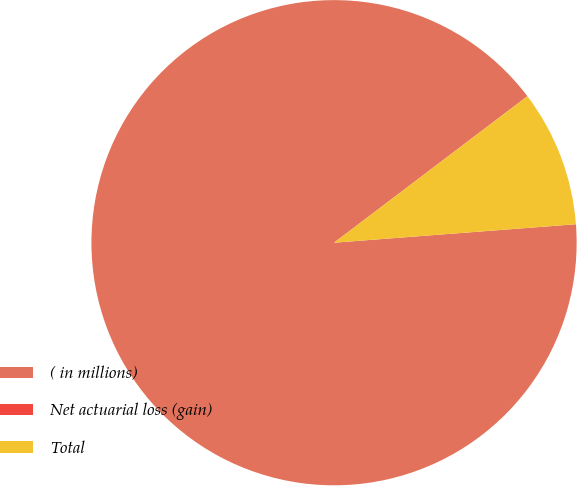<chart> <loc_0><loc_0><loc_500><loc_500><pie_chart><fcel>( in millions)<fcel>Net actuarial loss (gain)<fcel>Total<nl><fcel>90.89%<fcel>0.01%<fcel>9.1%<nl></chart> 